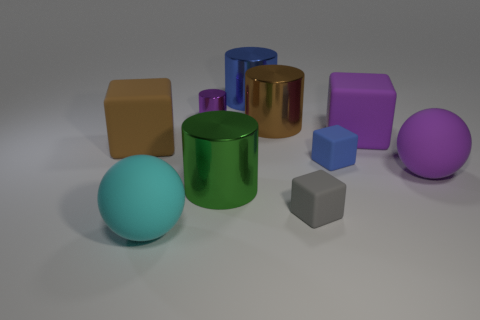The gray rubber cube is what size?
Provide a short and direct response. Small. Do the blue cylinder and the purple metallic cylinder have the same size?
Provide a succinct answer. No. There is a small object that is behind the gray thing and right of the purple shiny cylinder; what is its shape?
Offer a terse response. Cube. There is a cylinder that is in front of the large brown matte object; what is its size?
Offer a terse response. Large. How many large brown objects are left of the purple matte cube that is in front of the big cylinder behind the purple cylinder?
Provide a short and direct response. 2. Are there any green metal objects behind the small gray object?
Provide a short and direct response. Yes. How many other objects are there of the same size as the brown block?
Your answer should be compact. 6. There is a big thing that is behind the blue block and to the left of the big blue thing; what is its material?
Your answer should be very brief. Rubber. There is a tiny object that is left of the green cylinder; is it the same shape as the large metal thing left of the big blue object?
Give a very brief answer. Yes. Are there any other things that have the same material as the big blue cylinder?
Provide a short and direct response. Yes. 